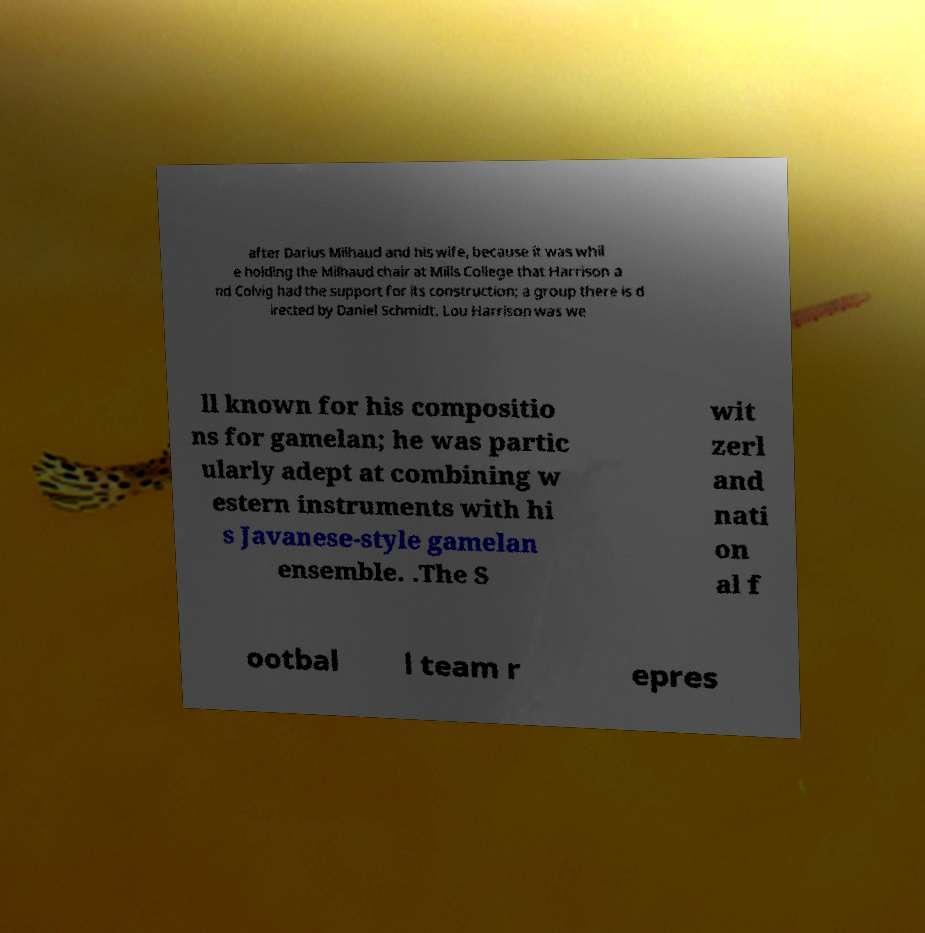What messages or text are displayed in this image? I need them in a readable, typed format. after Darius Milhaud and his wife, because it was whil e holding the Milhaud chair at Mills College that Harrison a nd Colvig had the support for its construction; a group there is d irected by Daniel Schmidt. Lou Harrison was we ll known for his compositio ns for gamelan; he was partic ularly adept at combining w estern instruments with hi s Javanese-style gamelan ensemble. .The S wit zerl and nati on al f ootbal l team r epres 